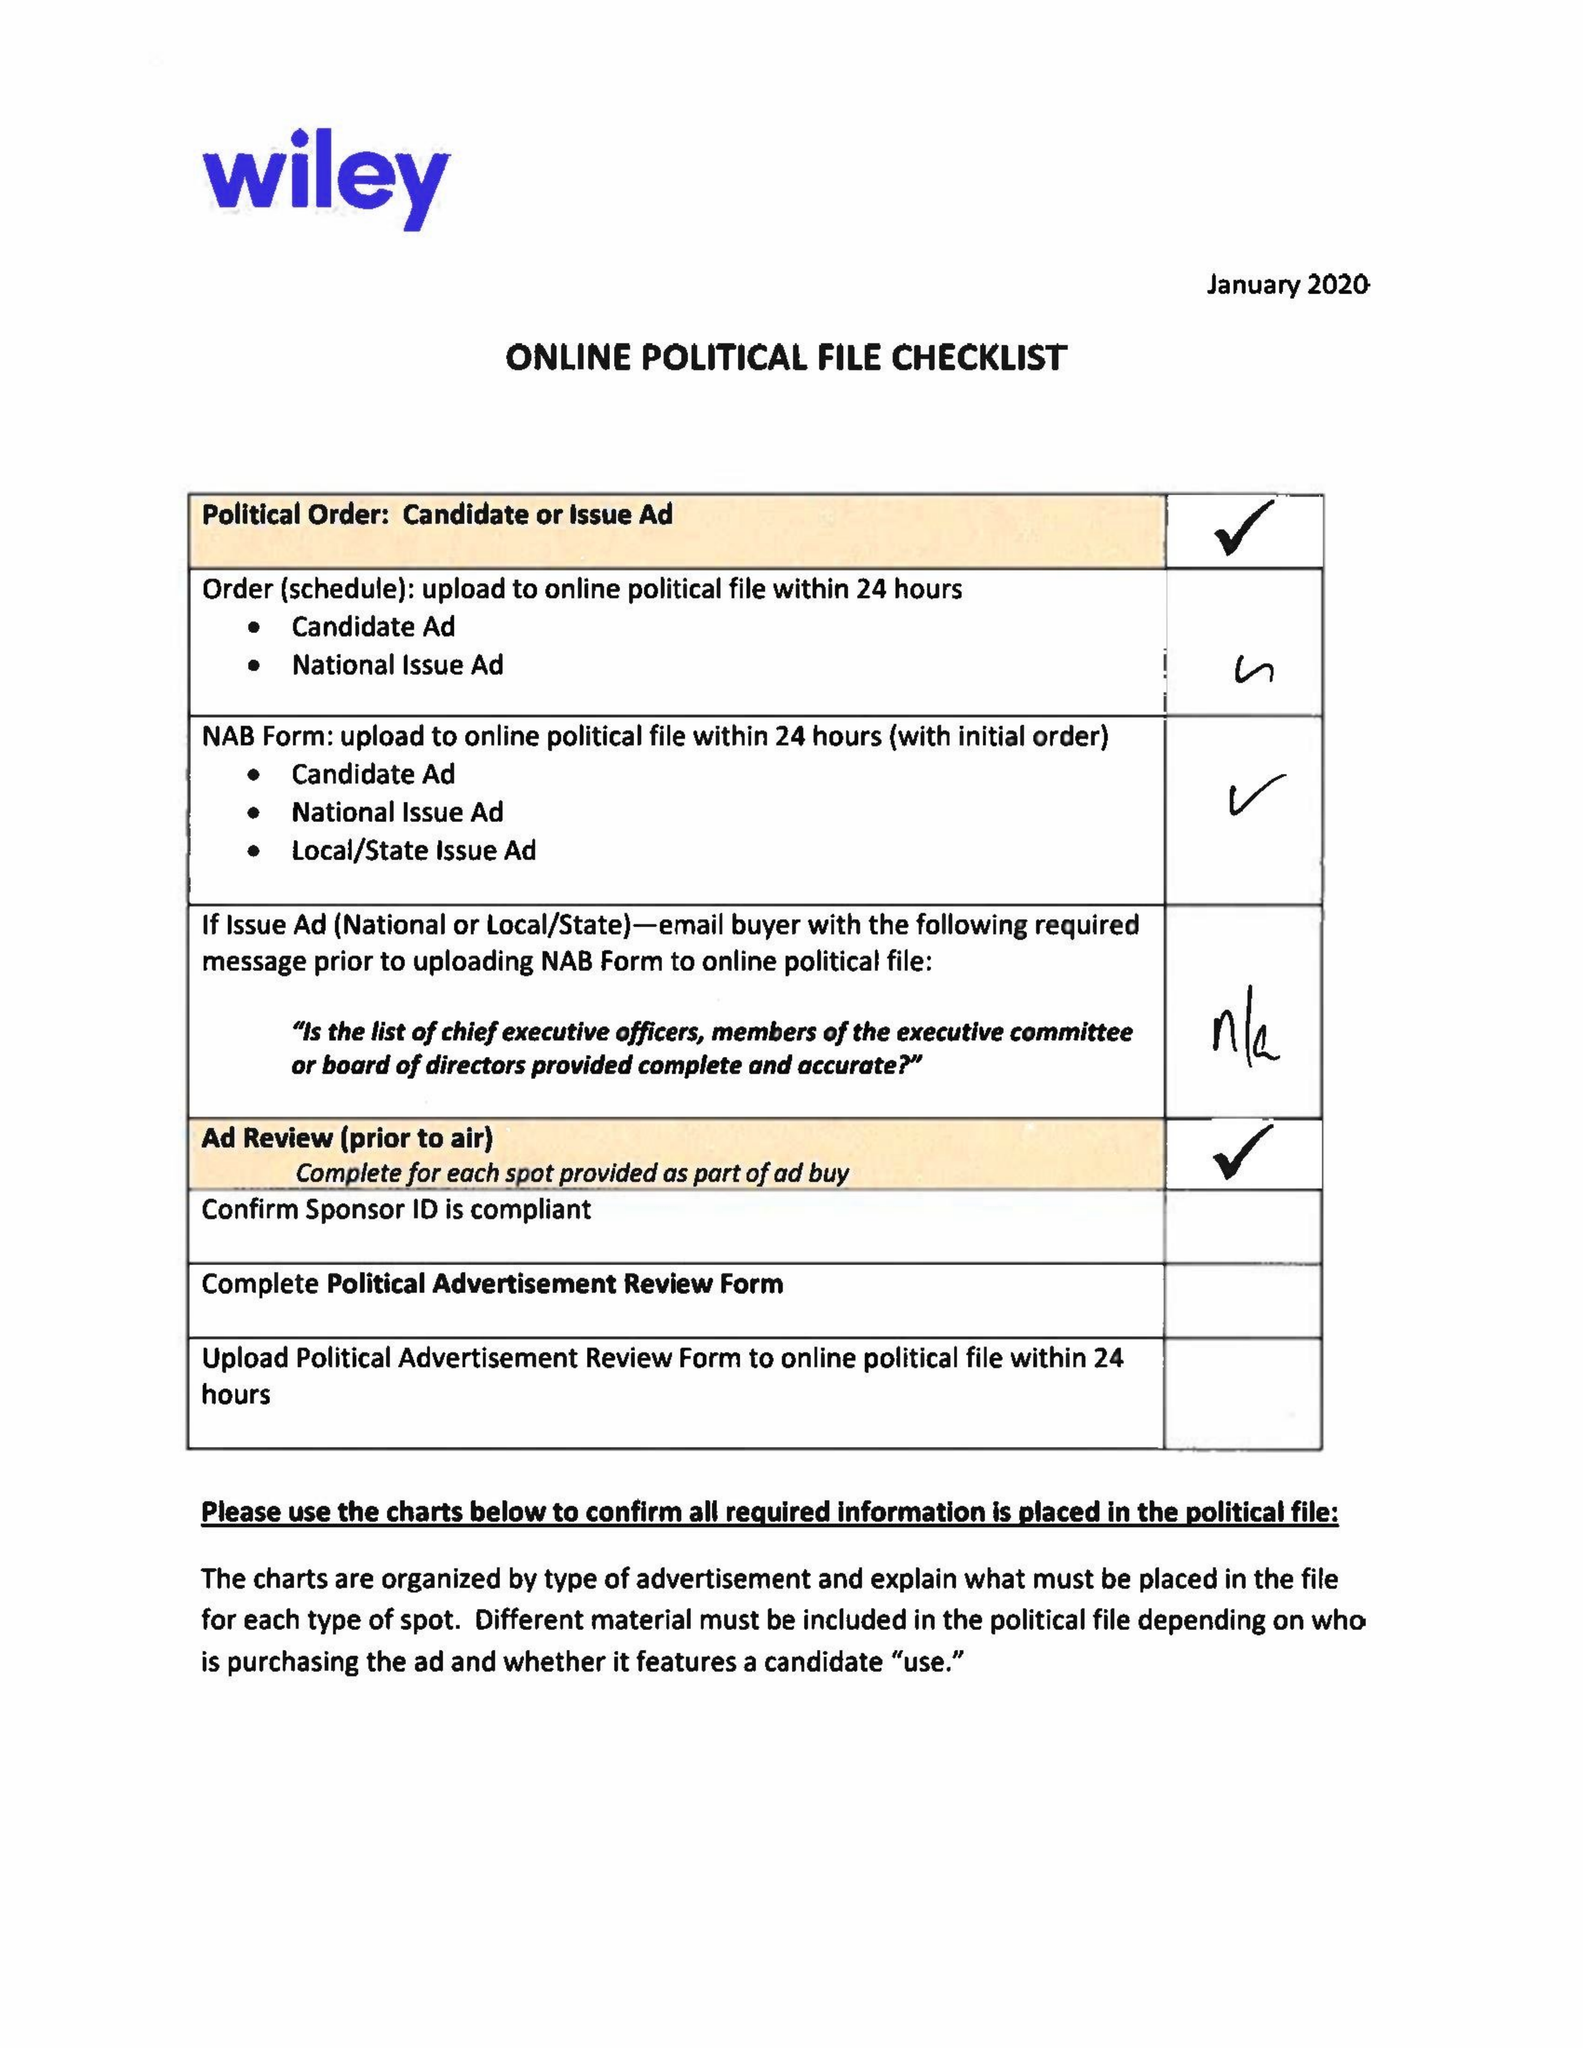What is the value for the advertiser?
Answer the question using a single word or phrase. COMMITTEE TO ELECT ROBIN LITAKER 